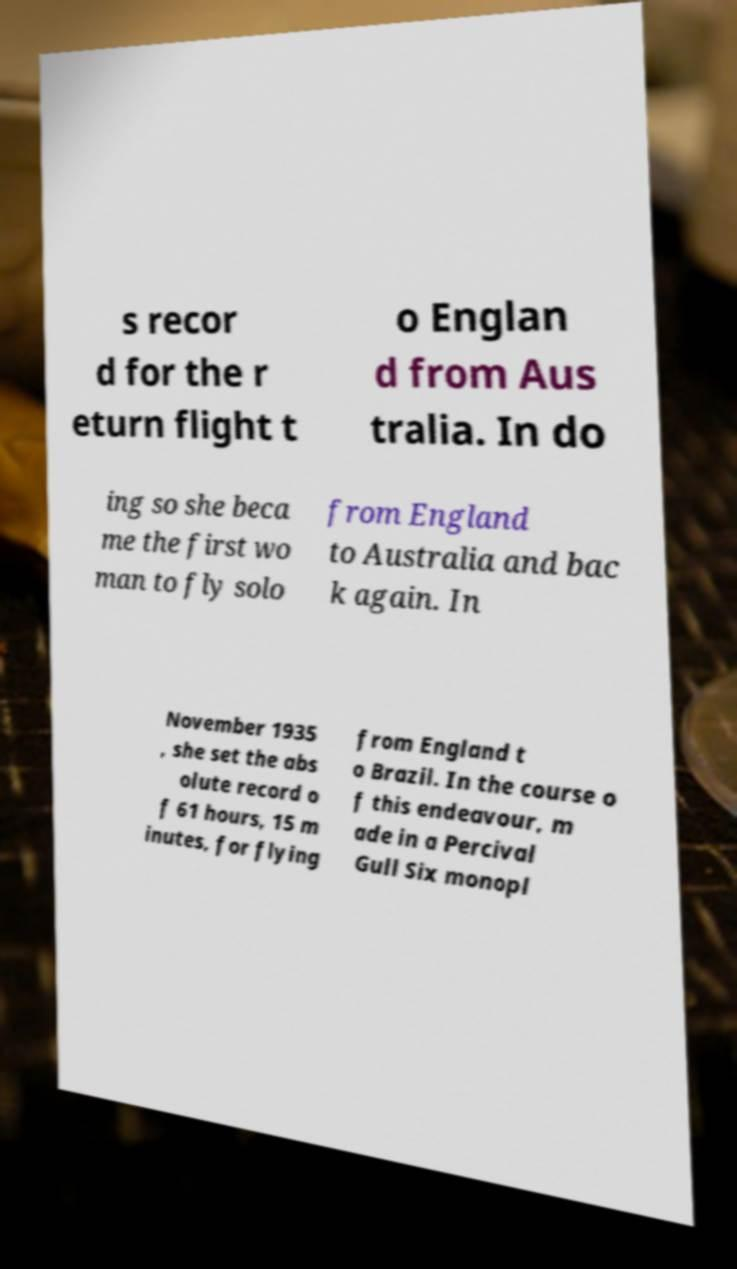I need the written content from this picture converted into text. Can you do that? s recor d for the r eturn flight t o Englan d from Aus tralia. In do ing so she beca me the first wo man to fly solo from England to Australia and bac k again. In November 1935 , she set the abs olute record o f 61 hours, 15 m inutes, for flying from England t o Brazil. In the course o f this endeavour, m ade in a Percival Gull Six monopl 